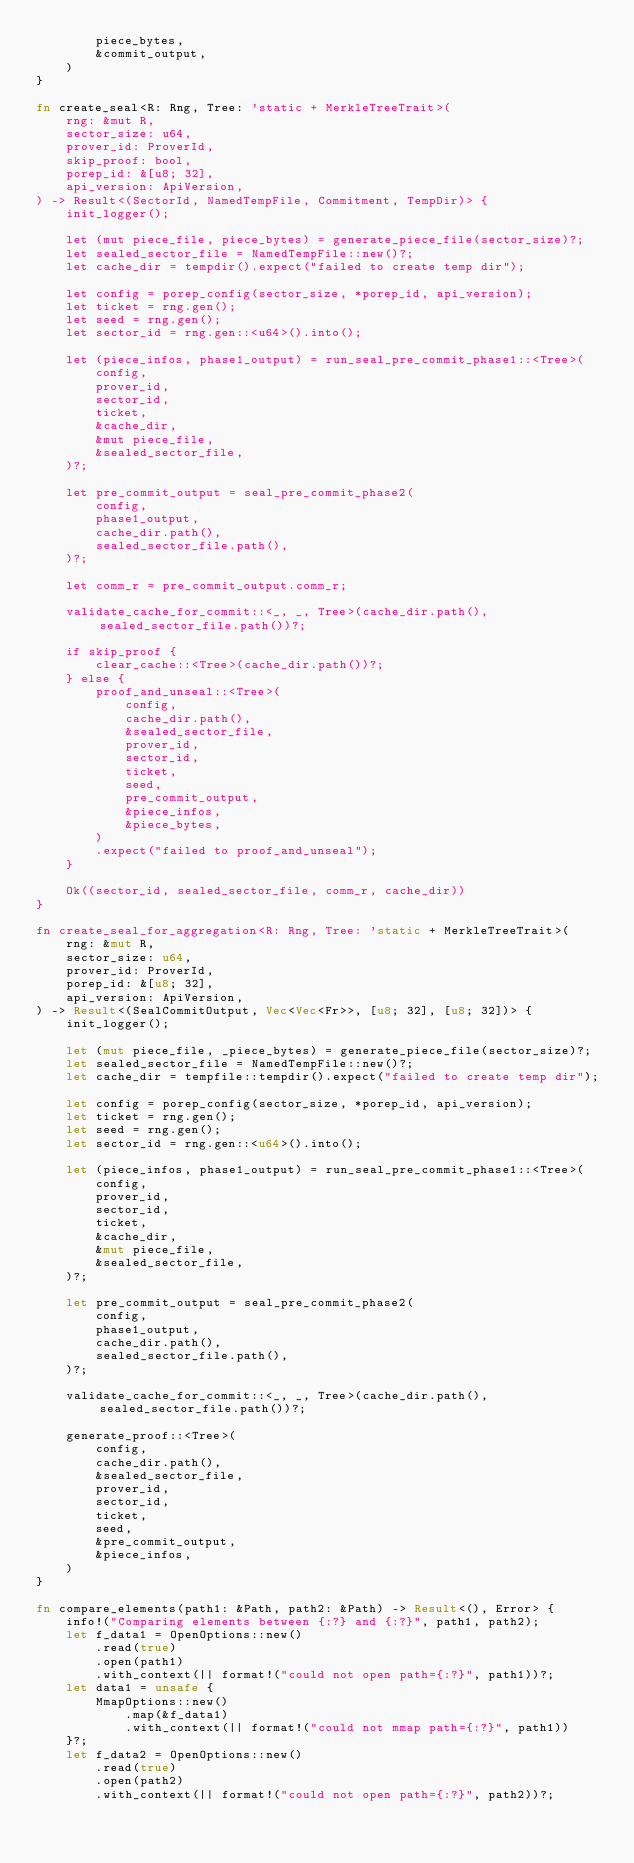<code> <loc_0><loc_0><loc_500><loc_500><_Rust_>        piece_bytes,
        &commit_output,
    )
}

fn create_seal<R: Rng, Tree: 'static + MerkleTreeTrait>(
    rng: &mut R,
    sector_size: u64,
    prover_id: ProverId,
    skip_proof: bool,
    porep_id: &[u8; 32],
    api_version: ApiVersion,
) -> Result<(SectorId, NamedTempFile, Commitment, TempDir)> {
    init_logger();

    let (mut piece_file, piece_bytes) = generate_piece_file(sector_size)?;
    let sealed_sector_file = NamedTempFile::new()?;
    let cache_dir = tempdir().expect("failed to create temp dir");

    let config = porep_config(sector_size, *porep_id, api_version);
    let ticket = rng.gen();
    let seed = rng.gen();
    let sector_id = rng.gen::<u64>().into();

    let (piece_infos, phase1_output) = run_seal_pre_commit_phase1::<Tree>(
        config,
        prover_id,
        sector_id,
        ticket,
        &cache_dir,
        &mut piece_file,
        &sealed_sector_file,
    )?;

    let pre_commit_output = seal_pre_commit_phase2(
        config,
        phase1_output,
        cache_dir.path(),
        sealed_sector_file.path(),
    )?;

    let comm_r = pre_commit_output.comm_r;

    validate_cache_for_commit::<_, _, Tree>(cache_dir.path(), sealed_sector_file.path())?;

    if skip_proof {
        clear_cache::<Tree>(cache_dir.path())?;
    } else {
        proof_and_unseal::<Tree>(
            config,
            cache_dir.path(),
            &sealed_sector_file,
            prover_id,
            sector_id,
            ticket,
            seed,
            pre_commit_output,
            &piece_infos,
            &piece_bytes,
        )
        .expect("failed to proof_and_unseal");
    }

    Ok((sector_id, sealed_sector_file, comm_r, cache_dir))
}

fn create_seal_for_aggregation<R: Rng, Tree: 'static + MerkleTreeTrait>(
    rng: &mut R,
    sector_size: u64,
    prover_id: ProverId,
    porep_id: &[u8; 32],
    api_version: ApiVersion,
) -> Result<(SealCommitOutput, Vec<Vec<Fr>>, [u8; 32], [u8; 32])> {
    init_logger();

    let (mut piece_file, _piece_bytes) = generate_piece_file(sector_size)?;
    let sealed_sector_file = NamedTempFile::new()?;
    let cache_dir = tempfile::tempdir().expect("failed to create temp dir");

    let config = porep_config(sector_size, *porep_id, api_version);
    let ticket = rng.gen();
    let seed = rng.gen();
    let sector_id = rng.gen::<u64>().into();

    let (piece_infos, phase1_output) = run_seal_pre_commit_phase1::<Tree>(
        config,
        prover_id,
        sector_id,
        ticket,
        &cache_dir,
        &mut piece_file,
        &sealed_sector_file,
    )?;

    let pre_commit_output = seal_pre_commit_phase2(
        config,
        phase1_output,
        cache_dir.path(),
        sealed_sector_file.path(),
    )?;

    validate_cache_for_commit::<_, _, Tree>(cache_dir.path(), sealed_sector_file.path())?;

    generate_proof::<Tree>(
        config,
        cache_dir.path(),
        &sealed_sector_file,
        prover_id,
        sector_id,
        ticket,
        seed,
        &pre_commit_output,
        &piece_infos,
    )
}

fn compare_elements(path1: &Path, path2: &Path) -> Result<(), Error> {
    info!("Comparing elements between {:?} and {:?}", path1, path2);
    let f_data1 = OpenOptions::new()
        .read(true)
        .open(path1)
        .with_context(|| format!("could not open path={:?}", path1))?;
    let data1 = unsafe {
        MmapOptions::new()
            .map(&f_data1)
            .with_context(|| format!("could not mmap path={:?}", path1))
    }?;
    let f_data2 = OpenOptions::new()
        .read(true)
        .open(path2)
        .with_context(|| format!("could not open path={:?}", path2))?;</code> 